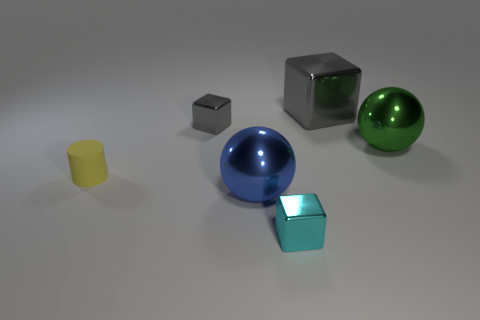Is there anything else that has the same material as the tiny cylinder?
Keep it short and to the point. No. What number of green spheres have the same size as the cyan metallic block?
Your answer should be compact. 0. How many big blue spheres are in front of the small block in front of the yellow cylinder?
Give a very brief answer. 0. There is a large sphere to the left of the large gray metal cube; does it have the same color as the tiny cylinder?
Offer a very short reply. No. There is a tiny block on the right side of the tiny gray shiny block behind the big blue ball; are there any objects that are right of it?
Provide a succinct answer. Yes. The small thing that is in front of the large green shiny sphere and to the right of the rubber cylinder has what shape?
Offer a terse response. Cube. Is there a thing of the same color as the large block?
Ensure brevity in your answer.  Yes. There is a tiny metal cube that is in front of the gray cube that is to the left of the big blue sphere; what color is it?
Your answer should be compact. Cyan. There is a gray metallic block in front of the large metal block behind the tiny gray cube that is on the right side of the rubber cylinder; how big is it?
Keep it short and to the point. Small. Are the yellow object and the tiny gray block to the right of the tiny yellow cylinder made of the same material?
Provide a short and direct response. No. 